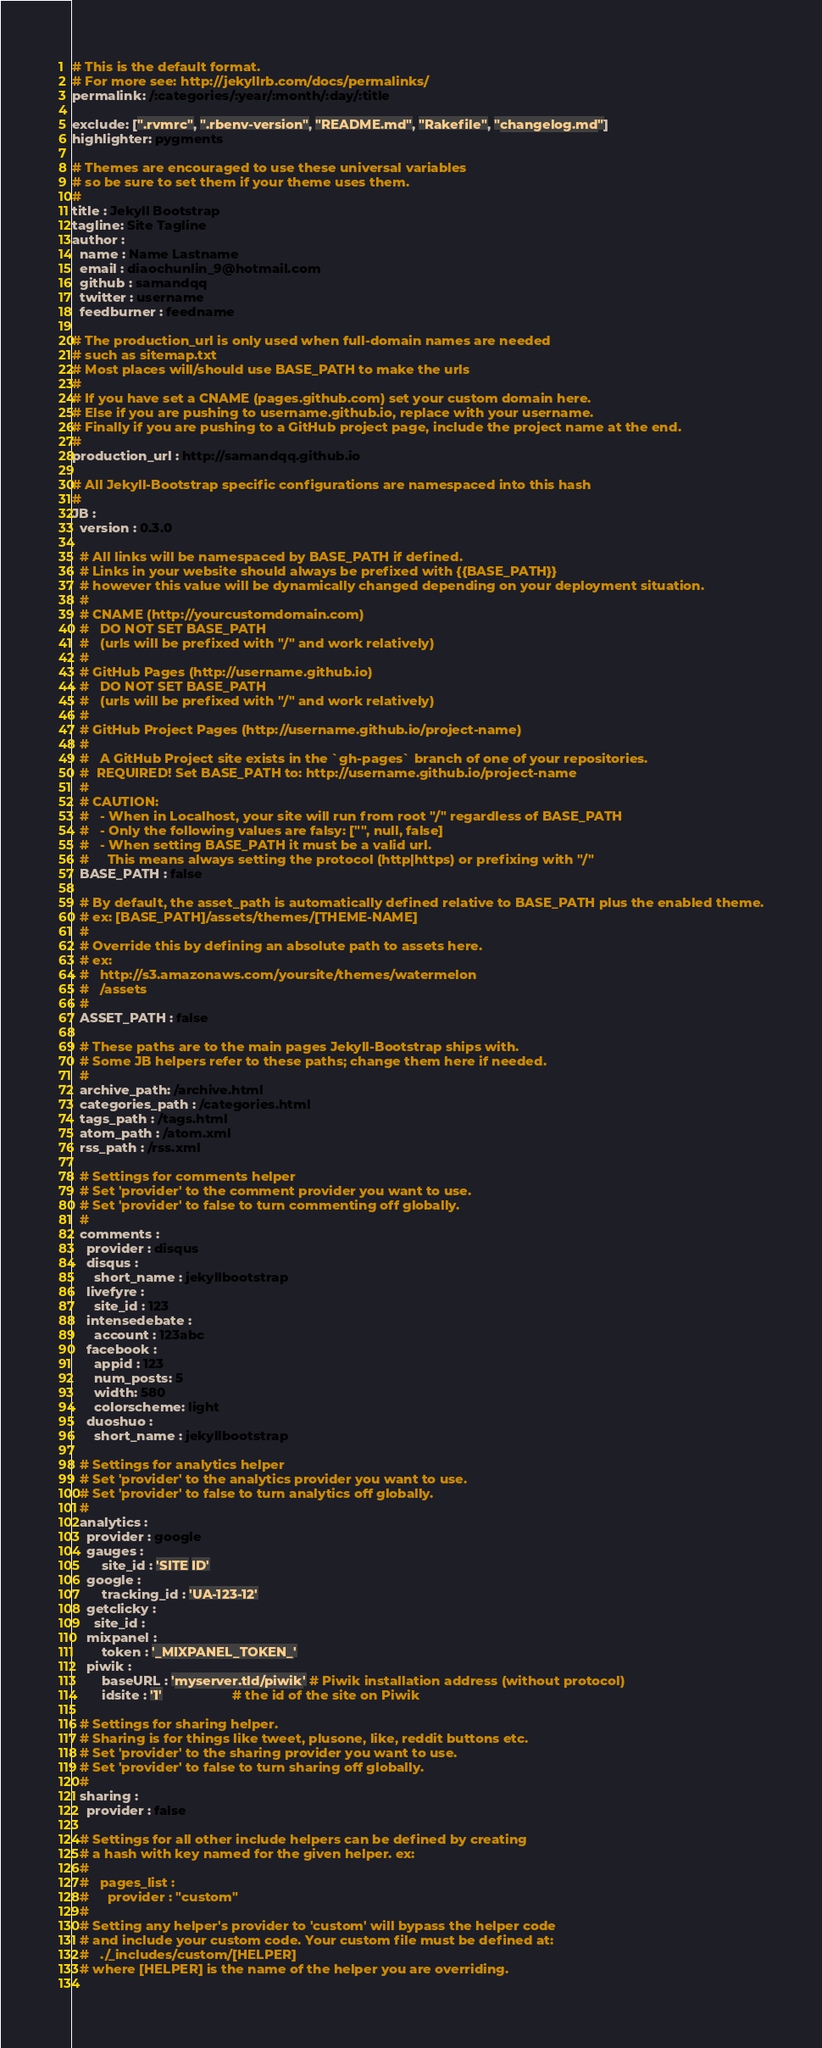Convert code to text. <code><loc_0><loc_0><loc_500><loc_500><_YAML_># This is the default format. 
# For more see: http://jekyllrb.com/docs/permalinks/
permalink: /:categories/:year/:month/:day/:title 

exclude: [".rvmrc", ".rbenv-version", "README.md", "Rakefile", "changelog.md"]
highlighter: pygments

# Themes are encouraged to use these universal variables 
# so be sure to set them if your theme uses them.
#
title : Jekyll Bootstrap
tagline: Site Tagline
author :
  name : Name Lastname
  email : diaochunlin_9@hotmail.com
  github : samandqq
  twitter : username
  feedburner : feedname

# The production_url is only used when full-domain names are needed
# such as sitemap.txt 
# Most places will/should use BASE_PATH to make the urls
#
# If you have set a CNAME (pages.github.com) set your custom domain here.
# Else if you are pushing to username.github.io, replace with your username.
# Finally if you are pushing to a GitHub project page, include the project name at the end.
#
production_url : http://samandqq.github.io

# All Jekyll-Bootstrap specific configurations are namespaced into this hash
#
JB :
  version : 0.3.0

  # All links will be namespaced by BASE_PATH if defined.
  # Links in your website should always be prefixed with {{BASE_PATH}}
  # however this value will be dynamically changed depending on your deployment situation.
  #
  # CNAME (http://yourcustomdomain.com)
  #   DO NOT SET BASE_PATH 
  #   (urls will be prefixed with "/" and work relatively)
  #
  # GitHub Pages (http://username.github.io)
  #   DO NOT SET BASE_PATH 
  #   (urls will be prefixed with "/" and work relatively)
  #
  # GitHub Project Pages (http://username.github.io/project-name)
  #
  #   A GitHub Project site exists in the `gh-pages` branch of one of your repositories.
  #  REQUIRED! Set BASE_PATH to: http://username.github.io/project-name
  #
  # CAUTION:
  #   - When in Localhost, your site will run from root "/" regardless of BASE_PATH
  #   - Only the following values are falsy: ["", null, false]
  #   - When setting BASE_PATH it must be a valid url.
  #     This means always setting the protocol (http|https) or prefixing with "/"
  BASE_PATH : false

  # By default, the asset_path is automatically defined relative to BASE_PATH plus the enabled theme.
  # ex: [BASE_PATH]/assets/themes/[THEME-NAME]
  #
  # Override this by defining an absolute path to assets here.
  # ex: 
  #   http://s3.amazonaws.com/yoursite/themes/watermelon
  #   /assets
  #
  ASSET_PATH : false

  # These paths are to the main pages Jekyll-Bootstrap ships with.
  # Some JB helpers refer to these paths; change them here if needed.
  #
  archive_path: /archive.html
  categories_path : /categories.html
  tags_path : /tags.html
  atom_path : /atom.xml
  rss_path : /rss.xml

  # Settings for comments helper
  # Set 'provider' to the comment provider you want to use.
  # Set 'provider' to false to turn commenting off globally.
  #
  comments :
    provider : disqus
    disqus :
      short_name : jekyllbootstrap
    livefyre :
      site_id : 123
    intensedebate :
      account : 123abc
    facebook :
      appid : 123
      num_posts: 5
      width: 580
      colorscheme: light
    duoshuo :
      short_name : jekyllbootstrap
   
  # Settings for analytics helper
  # Set 'provider' to the analytics provider you want to use.
  # Set 'provider' to false to turn analytics off globally.
  #        
  analytics :
    provider : google
    gauges :
        site_id : 'SITE ID'
    google : 
        tracking_id : 'UA-123-12'
    getclicky :
      site_id : 
    mixpanel :
        token : '_MIXPANEL_TOKEN_'
    piwik :
        baseURL : 'myserver.tld/piwik' # Piwik installation address (without protocol)
        idsite : '1'                   # the id of the site on Piwik

  # Settings for sharing helper. 
  # Sharing is for things like tweet, plusone, like, reddit buttons etc.
  # Set 'provider' to the sharing provider you want to use.
  # Set 'provider' to false to turn sharing off globally.
  #
  sharing :
    provider : false
    
  # Settings for all other include helpers can be defined by creating 
  # a hash with key named for the given helper. ex:
  #
  #   pages_list :
  #     provider : "custom"   
  #
  # Setting any helper's provider to 'custom' will bypass the helper code
  # and include your custom code. Your custom file must be defined at:
  #   ./_includes/custom/[HELPER]
  # where [HELPER] is the name of the helper you are overriding.
  
</code> 